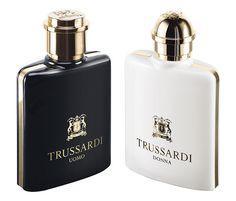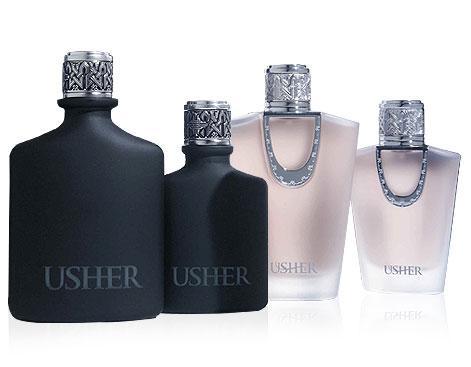The first image is the image on the left, the second image is the image on the right. Assess this claim about the two images: "One image shows a container of perfume and the box it is sold in, while a second image shows two or more bottles of cologne arranged side by side.". Correct or not? Answer yes or no. No. The first image is the image on the left, the second image is the image on the right. For the images shown, is this caption "At least one image contains a richly colored glass bottle with a sculpted shape." true? Answer yes or no. No. 